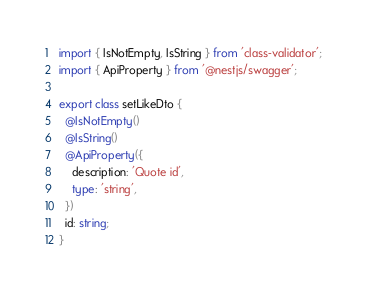Convert code to text. <code><loc_0><loc_0><loc_500><loc_500><_TypeScript_>import { IsNotEmpty, IsString } from 'class-validator';
import { ApiProperty } from '@nestjs/swagger';

export class setLikeDto {
  @IsNotEmpty()
  @IsString()
  @ApiProperty({
    description: 'Quote id',
    type: 'string',
  })
  id: string;
}
</code> 